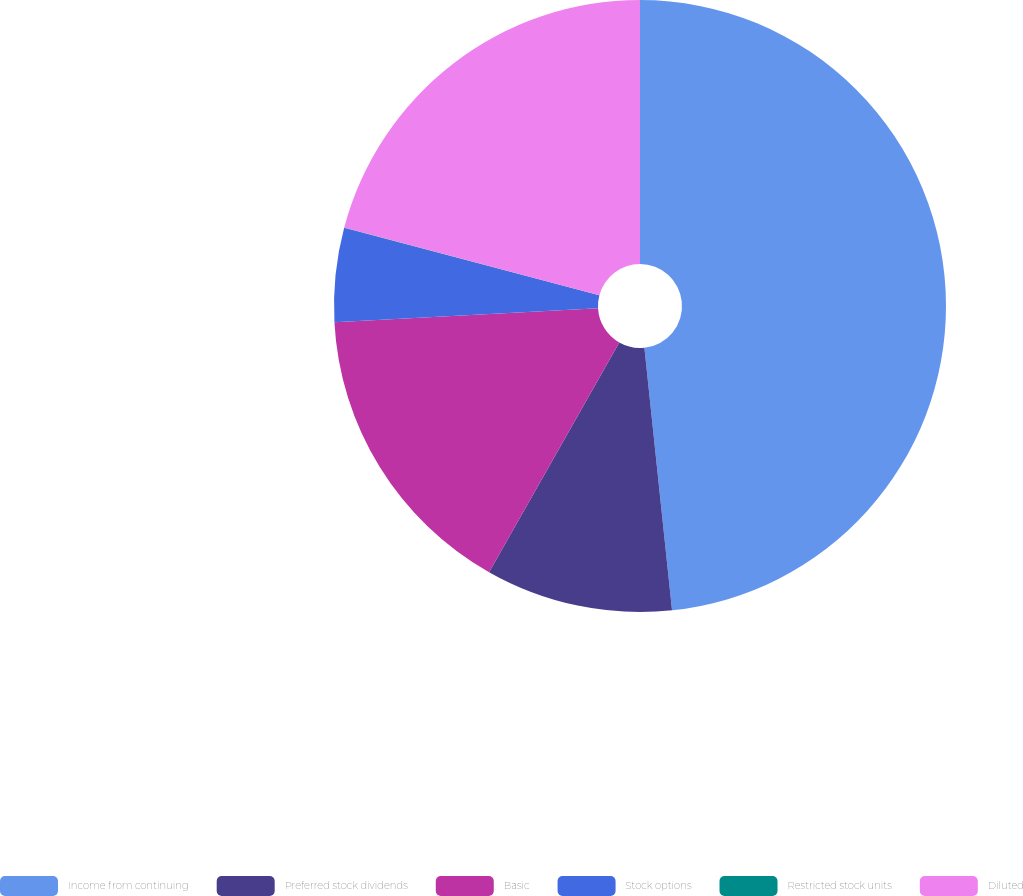<chart> <loc_0><loc_0><loc_500><loc_500><pie_chart><fcel>Income from continuing<fcel>Preferred stock dividends<fcel>Basic<fcel>Stock options<fcel>Restricted stock units<fcel>Diluted<nl><fcel>48.33%<fcel>9.88%<fcel>15.95%<fcel>4.95%<fcel>0.02%<fcel>20.87%<nl></chart> 